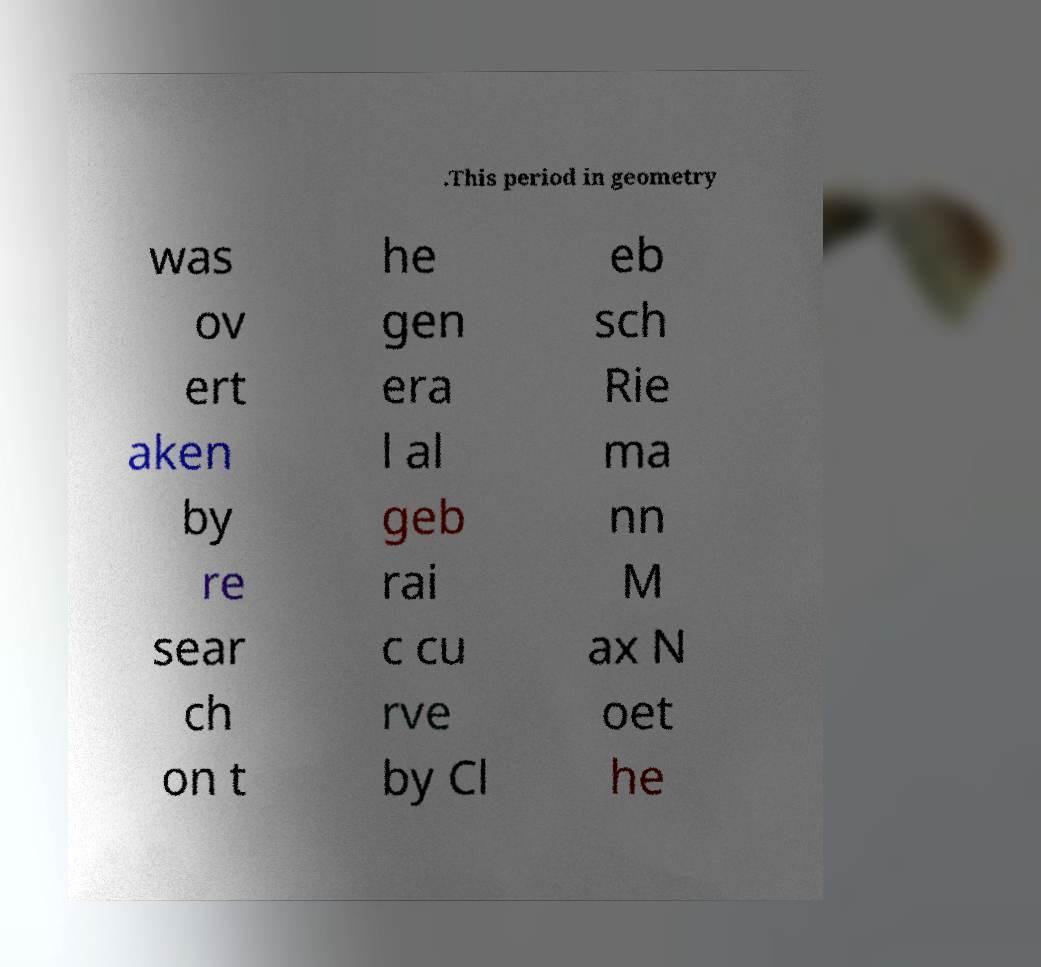Can you accurately transcribe the text from the provided image for me? .This period in geometry was ov ert aken by re sear ch on t he gen era l al geb rai c cu rve by Cl eb sch Rie ma nn M ax N oet he 